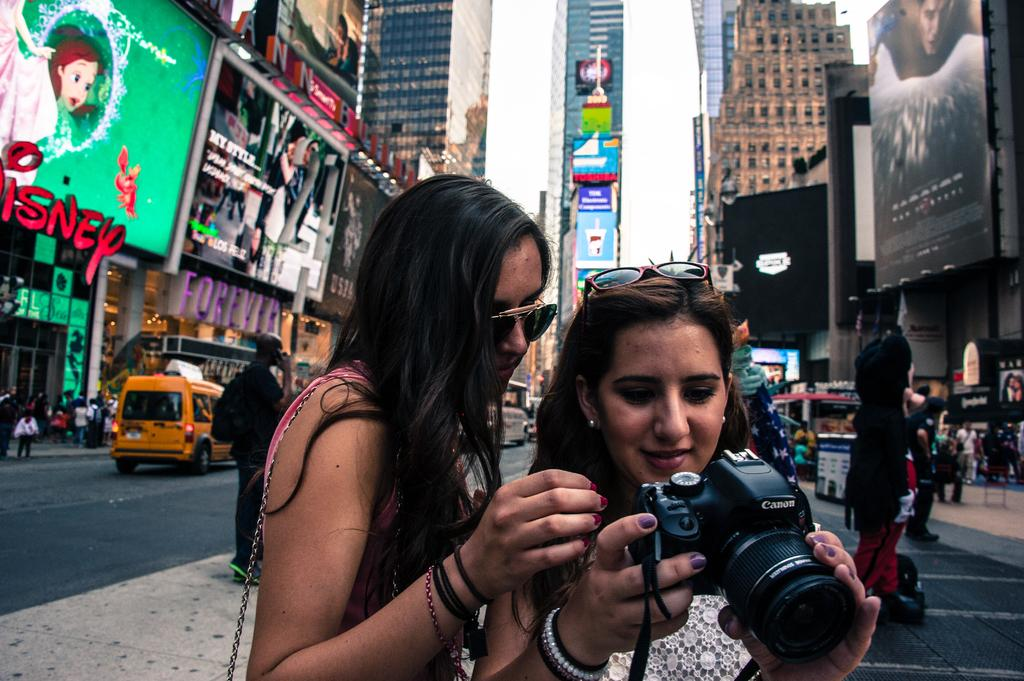<image>
Summarize the visual content of the image. Two women in the street, the word Disney is available to the left of them. 